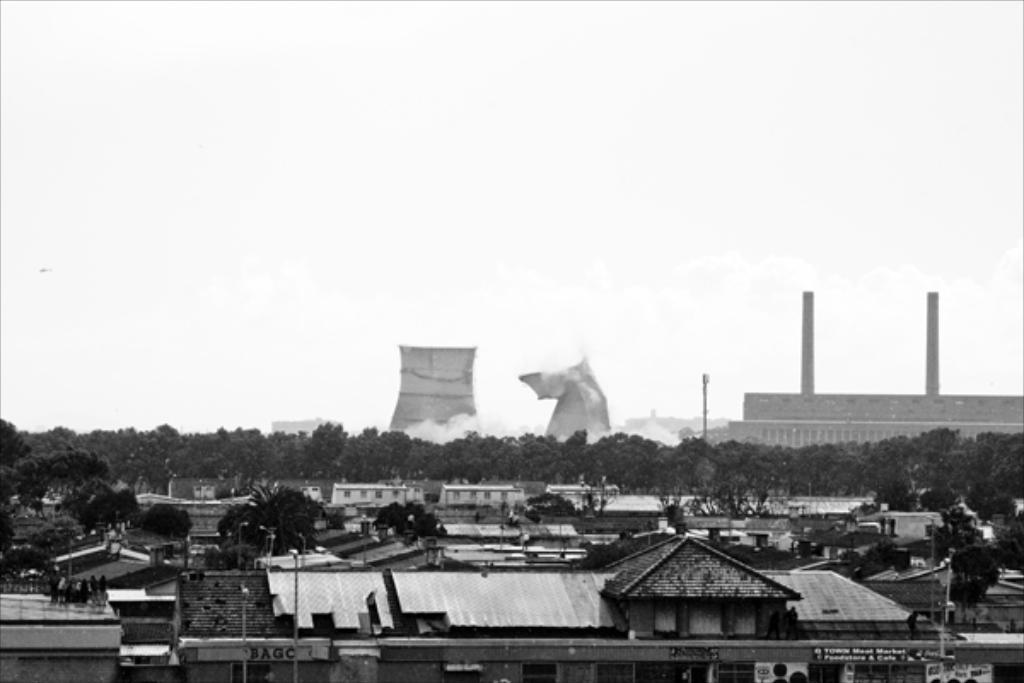What type of structures can be seen in the image? There are many buildings in the image. What else can be seen besides the buildings? There are poles and trees visible in the image. What is visible in the background of the image? The sky is visible in the background of the image. Where is the jar of smoke located in the image? There is no jar of smoke present in the image. What type of mailbox can be seen near the trees in the image? There is no mailbox present in the image. 